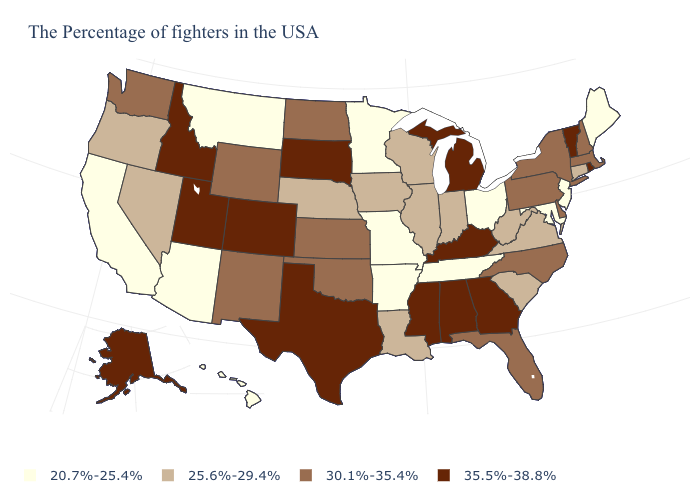Does New Jersey have the lowest value in the USA?
Concise answer only. Yes. What is the lowest value in the West?
Give a very brief answer. 20.7%-25.4%. Which states have the highest value in the USA?
Give a very brief answer. Rhode Island, Vermont, Georgia, Michigan, Kentucky, Alabama, Mississippi, Texas, South Dakota, Colorado, Utah, Idaho, Alaska. What is the value of Virginia?
Give a very brief answer. 25.6%-29.4%. What is the value of Nevada?
Keep it brief. 25.6%-29.4%. Does Maine have a higher value than South Carolina?
Be succinct. No. What is the value of North Carolina?
Answer briefly. 30.1%-35.4%. Does the map have missing data?
Quick response, please. No. What is the value of Delaware?
Answer briefly. 30.1%-35.4%. What is the value of Kansas?
Answer briefly. 30.1%-35.4%. Among the states that border Montana , does Idaho have the lowest value?
Concise answer only. No. What is the highest value in the West ?
Short answer required. 35.5%-38.8%. Name the states that have a value in the range 35.5%-38.8%?
Answer briefly. Rhode Island, Vermont, Georgia, Michigan, Kentucky, Alabama, Mississippi, Texas, South Dakota, Colorado, Utah, Idaho, Alaska. Name the states that have a value in the range 35.5%-38.8%?
Concise answer only. Rhode Island, Vermont, Georgia, Michigan, Kentucky, Alabama, Mississippi, Texas, South Dakota, Colorado, Utah, Idaho, Alaska. How many symbols are there in the legend?
Short answer required. 4. 